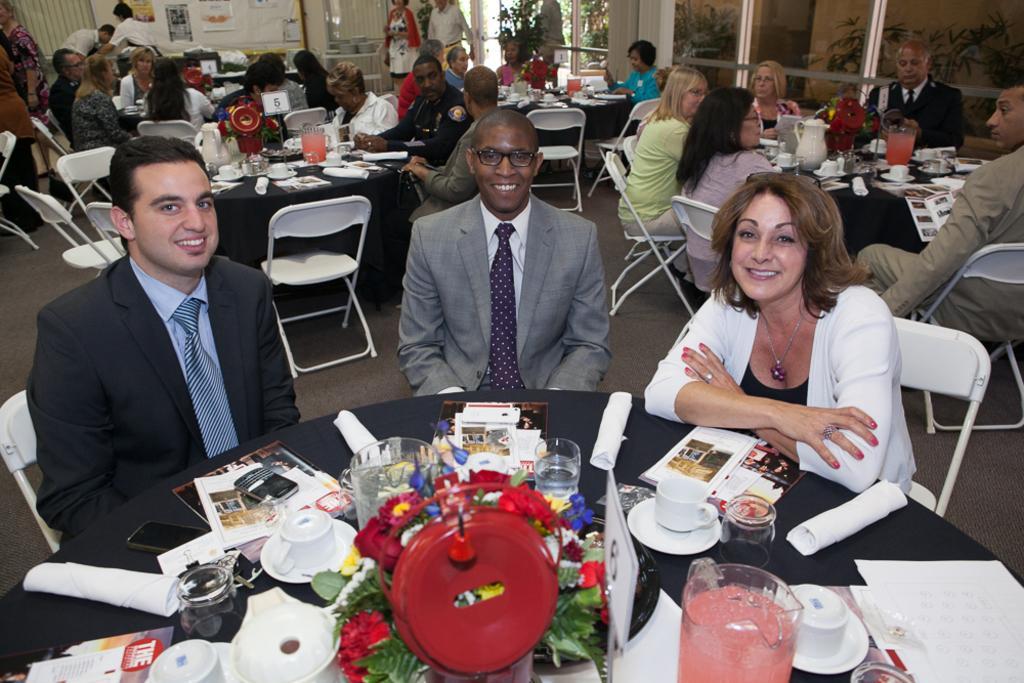In one or two sentences, can you explain what this image depicts? In this picture we can see a group of people sitting on chair and in front of them there is table and on table we can see jars, cup, saucer, paper, flower, mobile and tissue paper and in front this three people are smiling and in background we can see wall with posters, tree. 